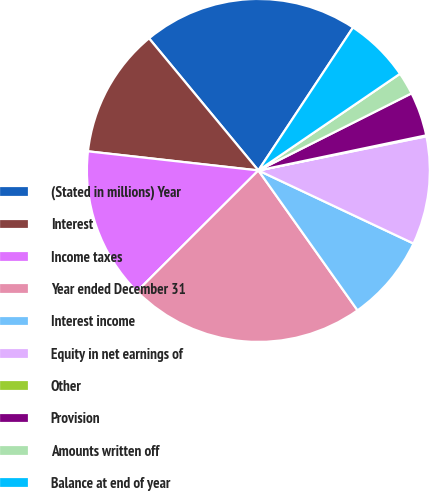Convert chart. <chart><loc_0><loc_0><loc_500><loc_500><pie_chart><fcel>(Stated in millions) Year<fcel>Interest<fcel>Income taxes<fcel>Year ended December 31<fcel>Interest income<fcel>Equity in net earnings of<fcel>Other<fcel>Provision<fcel>Amounts written off<fcel>Balance at end of year<nl><fcel>20.31%<fcel>12.22%<fcel>14.25%<fcel>22.34%<fcel>8.18%<fcel>10.2%<fcel>0.09%<fcel>4.14%<fcel>2.11%<fcel>6.16%<nl></chart> 